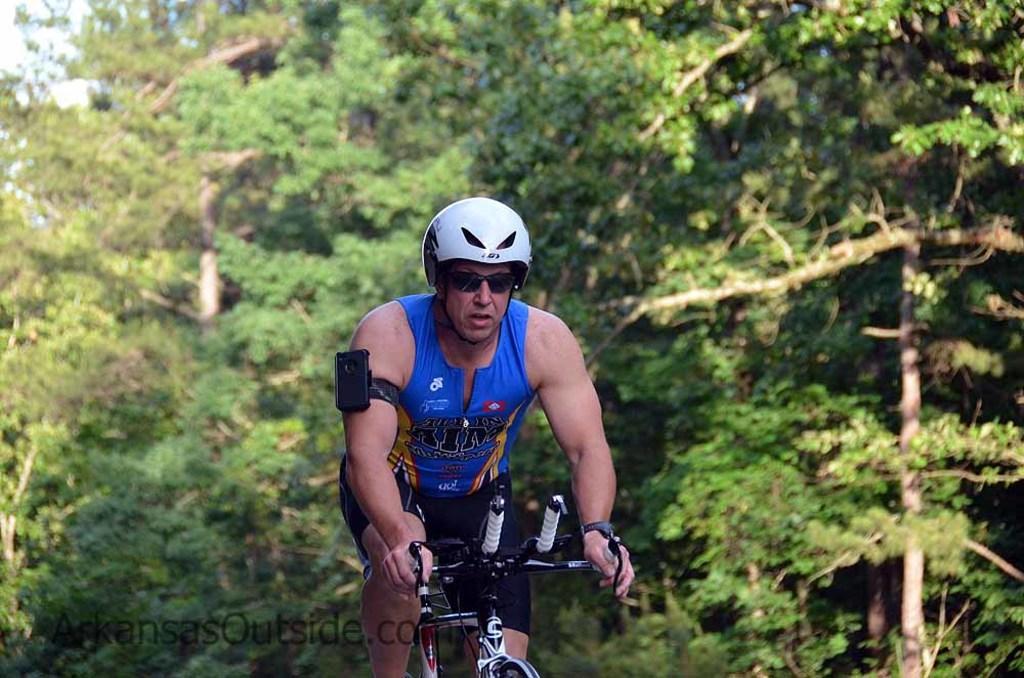Please provide a concise description of this image. In this image we can see a man riding the bicycle. In the background there are trees and sky. 